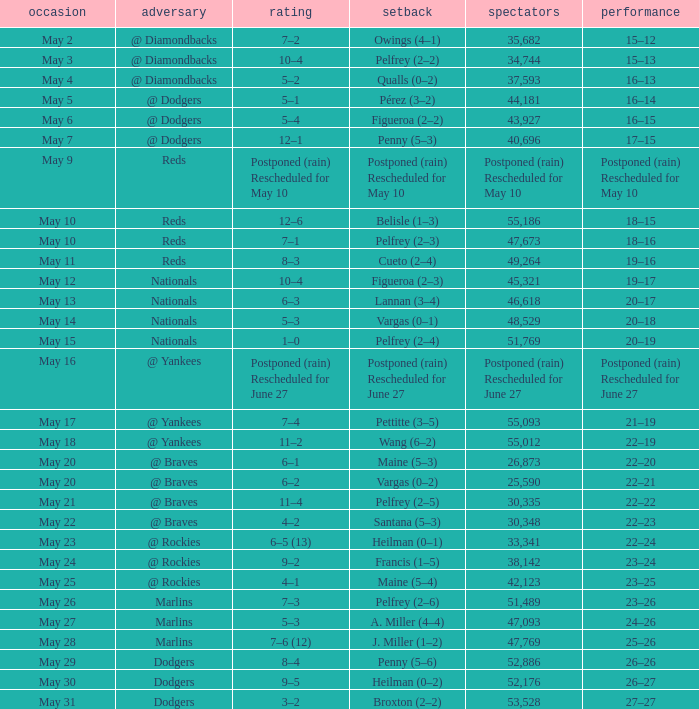Loss of postponed (rain) rescheduled for may 10 had what record? Postponed (rain) Rescheduled for May 10. Can you give me this table as a dict? {'header': ['occasion', 'adversary', 'rating', 'setback', 'spectators', 'performance'], 'rows': [['May 2', '@ Diamondbacks', '7–2', 'Owings (4–1)', '35,682', '15–12'], ['May 3', '@ Diamondbacks', '10–4', 'Pelfrey (2–2)', '34,744', '15–13'], ['May 4', '@ Diamondbacks', '5–2', 'Qualls (0–2)', '37,593', '16–13'], ['May 5', '@ Dodgers', '5–1', 'Pérez (3–2)', '44,181', '16–14'], ['May 6', '@ Dodgers', '5–4', 'Figueroa (2–2)', '43,927', '16–15'], ['May 7', '@ Dodgers', '12–1', 'Penny (5–3)', '40,696', '17–15'], ['May 9', 'Reds', 'Postponed (rain) Rescheduled for May 10', 'Postponed (rain) Rescheduled for May 10', 'Postponed (rain) Rescheduled for May 10', 'Postponed (rain) Rescheduled for May 10'], ['May 10', 'Reds', '12–6', 'Belisle (1–3)', '55,186', '18–15'], ['May 10', 'Reds', '7–1', 'Pelfrey (2–3)', '47,673', '18–16'], ['May 11', 'Reds', '8–3', 'Cueto (2–4)', '49,264', '19–16'], ['May 12', 'Nationals', '10–4', 'Figueroa (2–3)', '45,321', '19–17'], ['May 13', 'Nationals', '6–3', 'Lannan (3–4)', '46,618', '20–17'], ['May 14', 'Nationals', '5–3', 'Vargas (0–1)', '48,529', '20–18'], ['May 15', 'Nationals', '1–0', 'Pelfrey (2–4)', '51,769', '20–19'], ['May 16', '@ Yankees', 'Postponed (rain) Rescheduled for June 27', 'Postponed (rain) Rescheduled for June 27', 'Postponed (rain) Rescheduled for June 27', 'Postponed (rain) Rescheduled for June 27'], ['May 17', '@ Yankees', '7–4', 'Pettitte (3–5)', '55,093', '21–19'], ['May 18', '@ Yankees', '11–2', 'Wang (6–2)', '55,012', '22–19'], ['May 20', '@ Braves', '6–1', 'Maine (5–3)', '26,873', '22–20'], ['May 20', '@ Braves', '6–2', 'Vargas (0–2)', '25,590', '22–21'], ['May 21', '@ Braves', '11–4', 'Pelfrey (2–5)', '30,335', '22–22'], ['May 22', '@ Braves', '4–2', 'Santana (5–3)', '30,348', '22–23'], ['May 23', '@ Rockies', '6–5 (13)', 'Heilman (0–1)', '33,341', '22–24'], ['May 24', '@ Rockies', '9–2', 'Francis (1–5)', '38,142', '23–24'], ['May 25', '@ Rockies', '4–1', 'Maine (5–4)', '42,123', '23–25'], ['May 26', 'Marlins', '7–3', 'Pelfrey (2–6)', '51,489', '23–26'], ['May 27', 'Marlins', '5–3', 'A. Miller (4–4)', '47,093', '24–26'], ['May 28', 'Marlins', '7–6 (12)', 'J. Miller (1–2)', '47,769', '25–26'], ['May 29', 'Dodgers', '8–4', 'Penny (5–6)', '52,886', '26–26'], ['May 30', 'Dodgers', '9–5', 'Heilman (0–2)', '52,176', '26–27'], ['May 31', 'Dodgers', '3–2', 'Broxton (2–2)', '53,528', '27–27']]} 